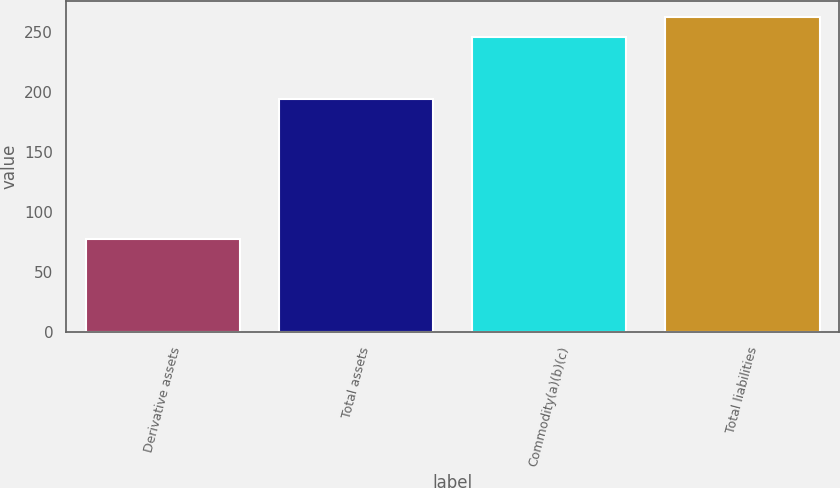Convert chart to OTSL. <chart><loc_0><loc_0><loc_500><loc_500><bar_chart><fcel>Derivative assets<fcel>Total assets<fcel>Commodity(a)(b)(c)<fcel>Total liabilities<nl><fcel>78<fcel>194<fcel>246<fcel>262.8<nl></chart> 